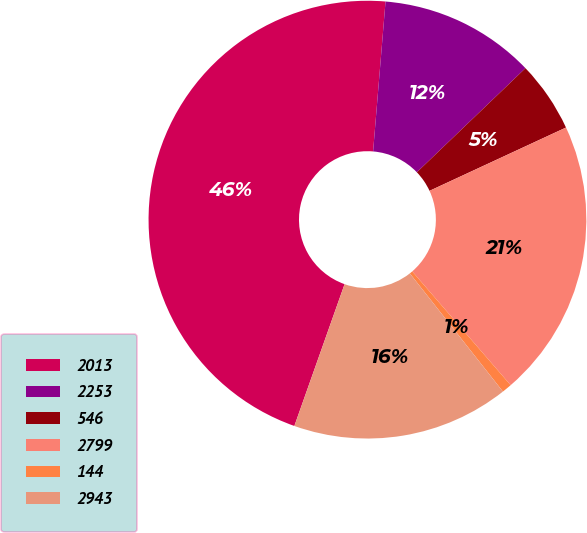<chart> <loc_0><loc_0><loc_500><loc_500><pie_chart><fcel>2013<fcel>2253<fcel>546<fcel>2799<fcel>144<fcel>2943<nl><fcel>45.9%<fcel>11.52%<fcel>5.25%<fcel>20.56%<fcel>0.73%<fcel>16.04%<nl></chart> 